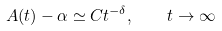<formula> <loc_0><loc_0><loc_500><loc_500>A ( t ) - \alpha \simeq C t ^ { - \delta } , \quad t \to \infty</formula> 